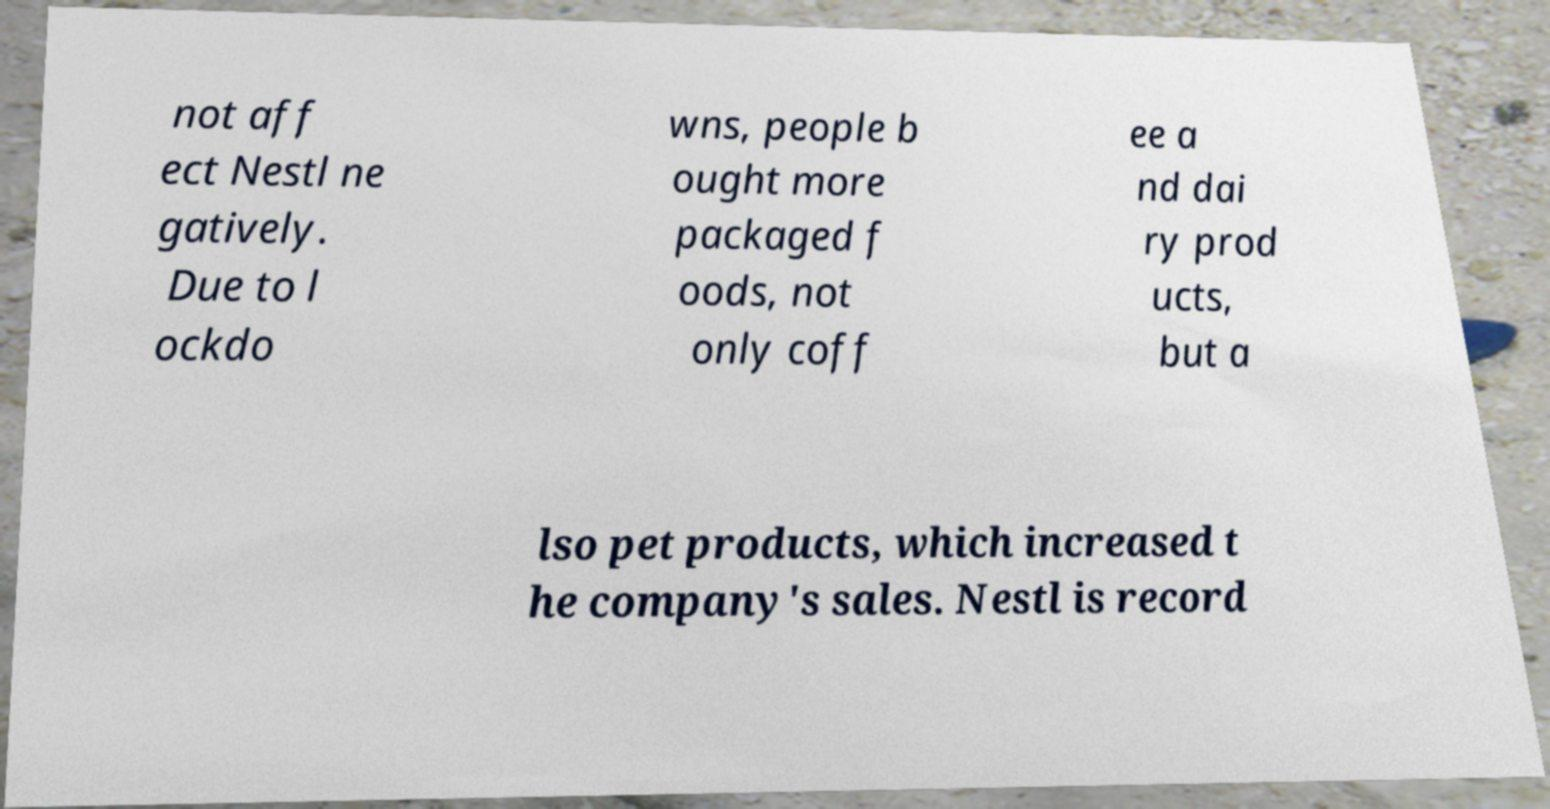For documentation purposes, I need the text within this image transcribed. Could you provide that? not aff ect Nestl ne gatively. Due to l ockdo wns, people b ought more packaged f oods, not only coff ee a nd dai ry prod ucts, but a lso pet products, which increased t he company's sales. Nestl is record 